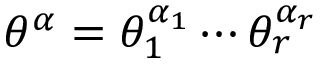Convert formula to latex. <formula><loc_0><loc_0><loc_500><loc_500>\theta ^ { \alpha } = \theta _ { 1 } ^ { \alpha _ { 1 } } \cdots \theta _ { r } ^ { \alpha _ { r } }</formula> 